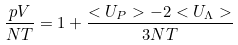Convert formula to latex. <formula><loc_0><loc_0><loc_500><loc_500>\frac { p V } { N T } = 1 + \frac { < U _ { P } > - 2 < U _ { \Lambda } > } { 3 N T }</formula> 